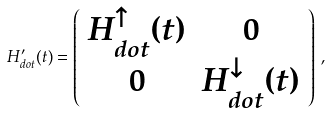<formula> <loc_0><loc_0><loc_500><loc_500>H _ { d o t } ^ { \prime } ( t ) = \left ( \begin{array} { c c } H ^ { \uparrow } _ { d o t } ( t ) & 0 \\ 0 & H ^ { \downarrow } _ { d o t } ( t ) \end{array} \right ) \, ,</formula> 